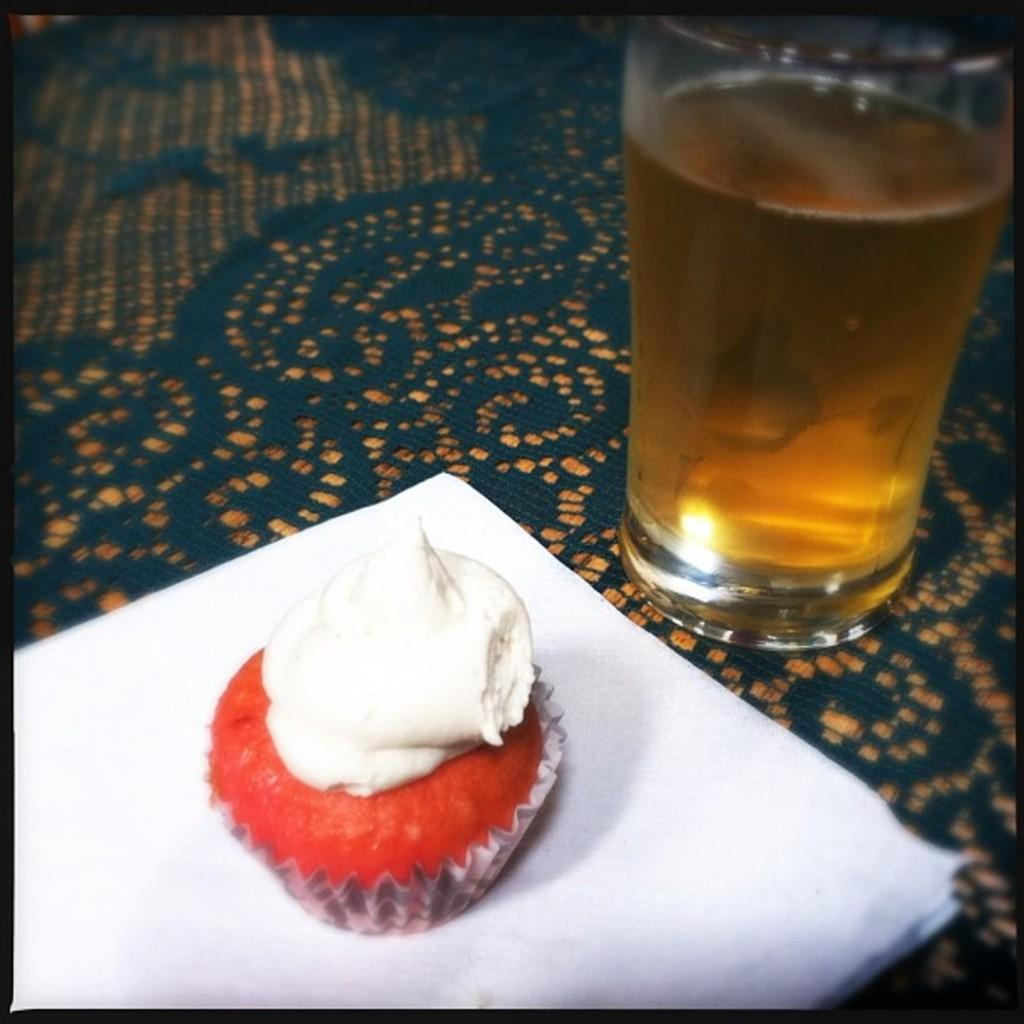What type of dessert is featured in the image? There is a cupcake with cream in the image. What can be used for cleaning or wiping in the image? Tissues are present in the image for cleaning or wiping. What beverage is visible on the table in the image? There is a glass of wine on a table in the image. What type of plant is growing in the glass of wine? There is no plant growing in the glass of wine; it contains wine. 